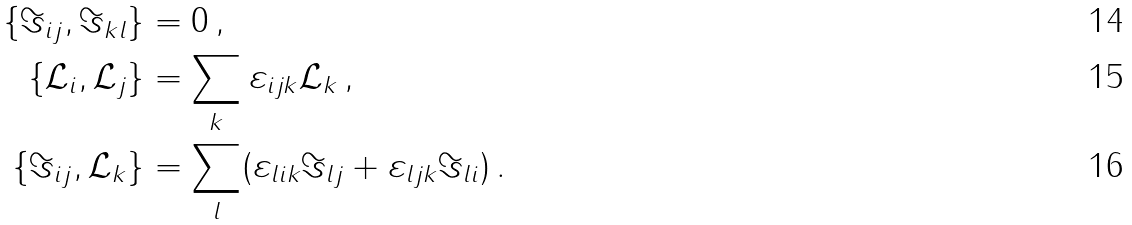<formula> <loc_0><loc_0><loc_500><loc_500>\{ \Im _ { i j } , \Im _ { k l } \} & = 0 \, , \\ \{ \mathcal { L } _ { i } , \mathcal { L } _ { j } \} & = \sum _ { k } \varepsilon _ { i j k } \mathcal { L } _ { k } \, , \\ \{ \Im _ { i j } , \mathcal { L } _ { k } \} & = \sum _ { l } ( \varepsilon _ { l i k } \Im _ { l j } + \varepsilon _ { l j k } \Im _ { l i } ) \, .</formula> 